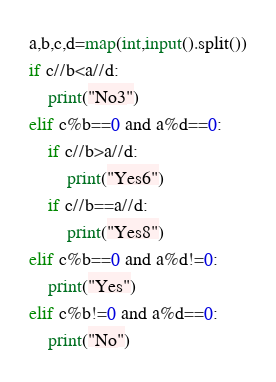Convert code to text. <code><loc_0><loc_0><loc_500><loc_500><_Python_>a,b,c,d=map(int,input().split())
if c//b<a//d:
    print("No3")
elif c%b==0 and a%d==0:
    if c//b>a//d:
        print("Yes6")
    if c//b==a//d:
        print("Yes8")
elif c%b==0 and a%d!=0:
    print("Yes")
elif c%b!=0 and a%d==0:
    print("No")</code> 